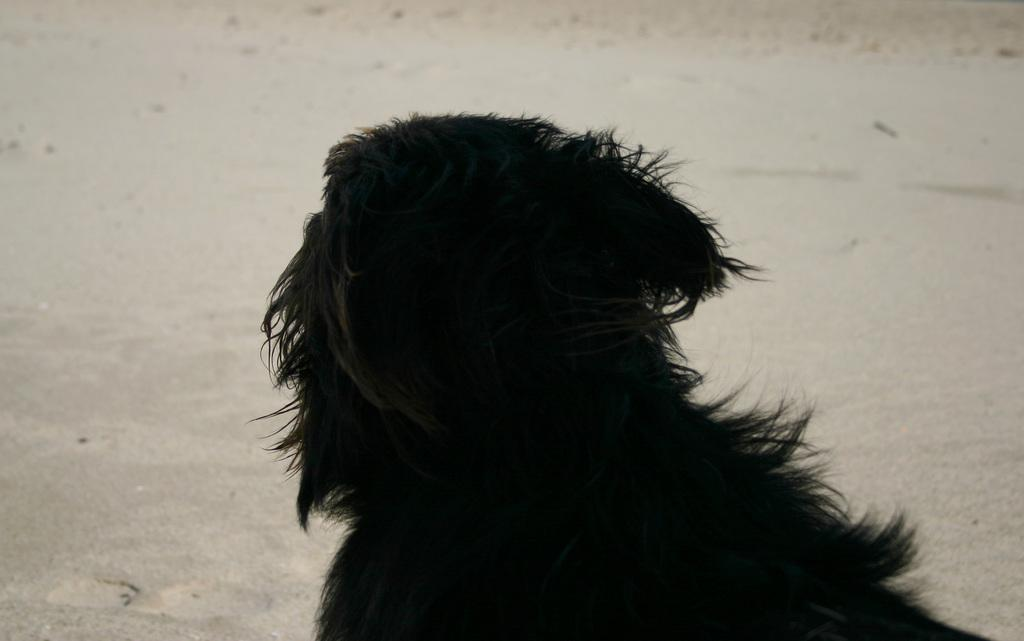What type of animal can be seen in the image? There is a black color animal in the image. Where is the animal located in the image? The animal is towards the bottom of the image. What can be seen in the background of the image? There is ground visible in the background of the image. What type of tax is being discussed in the image? There is no discussion of tax in the image; it features a black color animal and ground in the background. What is the texture of the animal's fur in the image? The texture of the animal's fur cannot be determined from the image, as the image does not provide enough detail to discern the texture. 